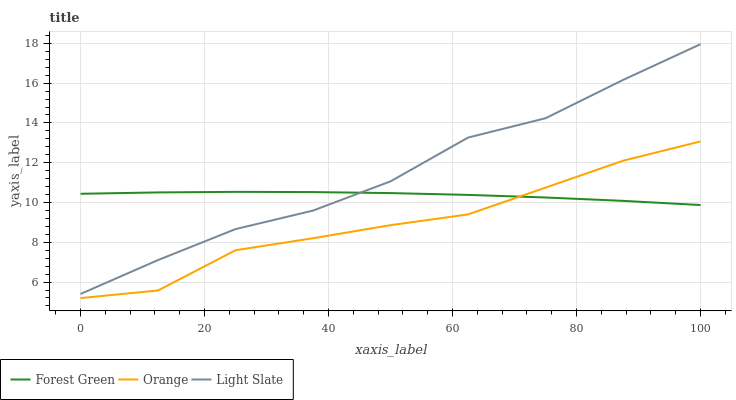Does Orange have the minimum area under the curve?
Answer yes or no. Yes. Does Light Slate have the maximum area under the curve?
Answer yes or no. Yes. Does Forest Green have the minimum area under the curve?
Answer yes or no. No. Does Forest Green have the maximum area under the curve?
Answer yes or no. No. Is Forest Green the smoothest?
Answer yes or no. Yes. Is Orange the roughest?
Answer yes or no. Yes. Is Light Slate the smoothest?
Answer yes or no. No. Is Light Slate the roughest?
Answer yes or no. No. Does Orange have the lowest value?
Answer yes or no. Yes. Does Light Slate have the lowest value?
Answer yes or no. No. Does Light Slate have the highest value?
Answer yes or no. Yes. Does Forest Green have the highest value?
Answer yes or no. No. Is Orange less than Light Slate?
Answer yes or no. Yes. Is Light Slate greater than Orange?
Answer yes or no. Yes. Does Light Slate intersect Forest Green?
Answer yes or no. Yes. Is Light Slate less than Forest Green?
Answer yes or no. No. Is Light Slate greater than Forest Green?
Answer yes or no. No. Does Orange intersect Light Slate?
Answer yes or no. No. 